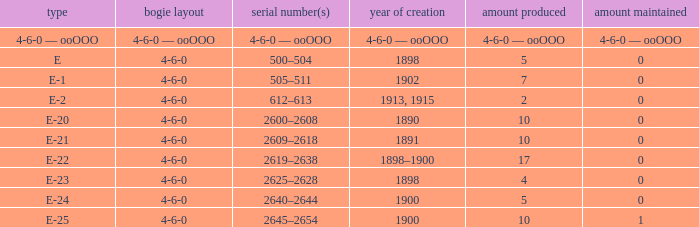What is the wheel arrangement with 1 quantity preserved? 4-6-0. 